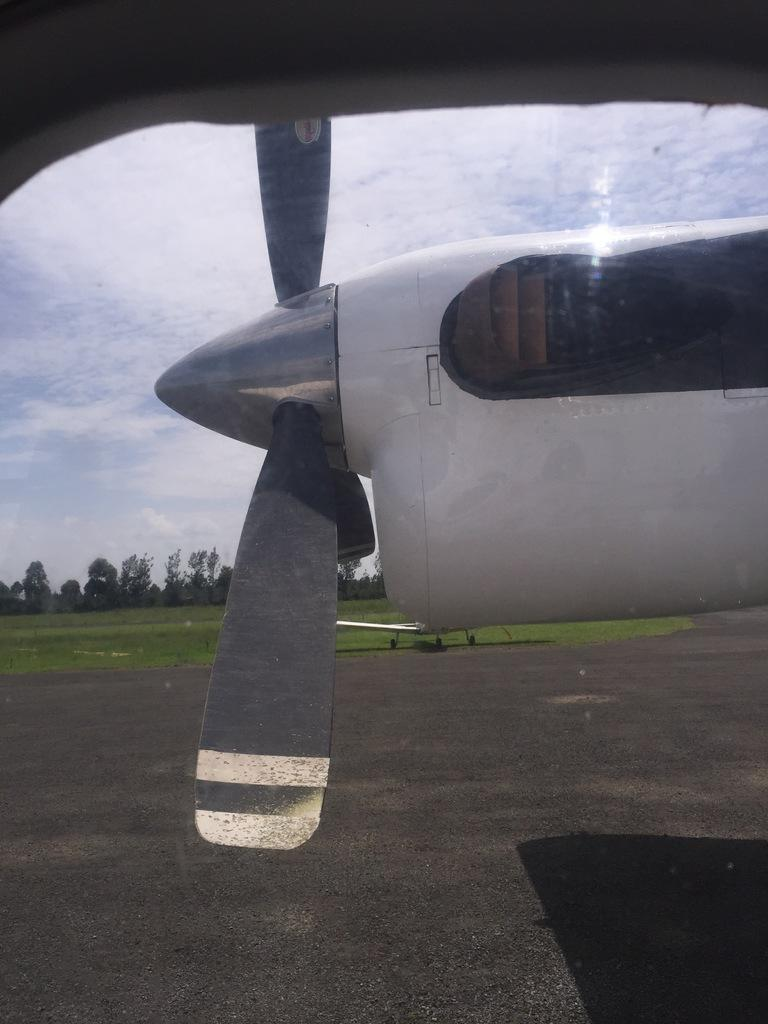What is located on the runway in the image? There is an aeroplane on the runway in the image. What type of vegetation can be seen in the background? There is grass in the background of the image. Are there any other aeroplanes visible in the image? Yes, there is another aeroplane in the background. What else can be seen in the background of the image? There are trees and the sky visible in the background. What is the condition of the sky in the image? The sky is visible in the background, and clouds are present. How does the aeroplane wash its debt in the image? There is no mention of debt in the image, and aeroplanes do not have the ability to wash anything. 